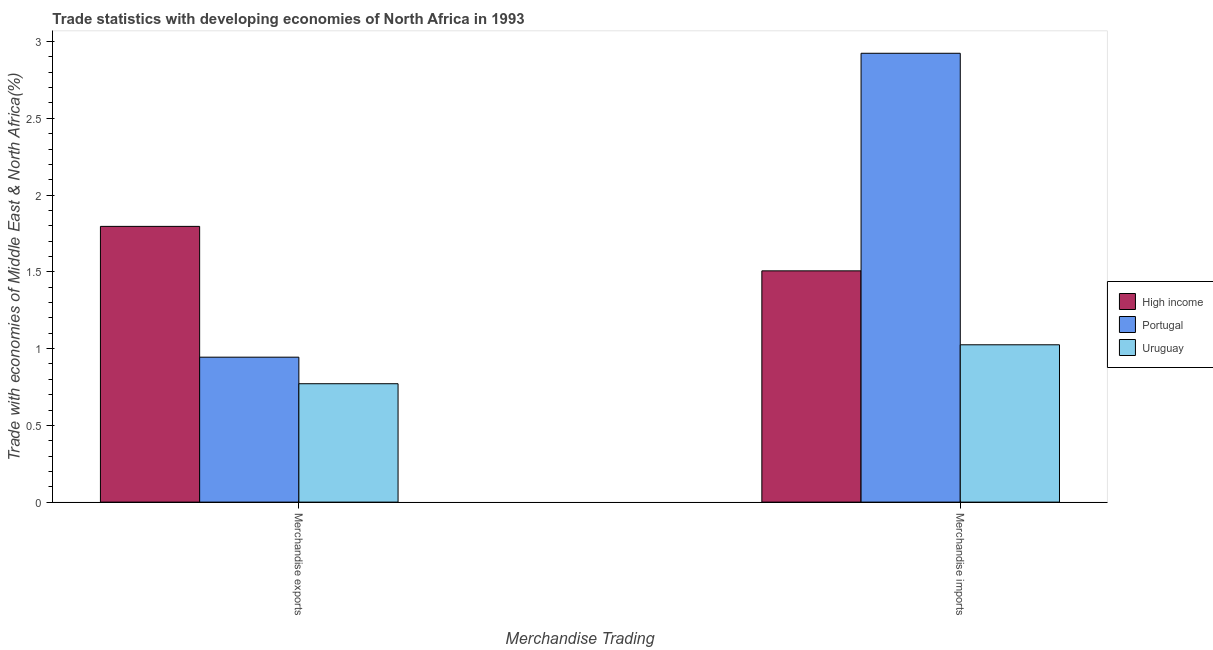How many different coloured bars are there?
Your answer should be very brief. 3. Are the number of bars per tick equal to the number of legend labels?
Your answer should be very brief. Yes. Are the number of bars on each tick of the X-axis equal?
Offer a terse response. Yes. How many bars are there on the 2nd tick from the right?
Your response must be concise. 3. What is the merchandise imports in Portugal?
Ensure brevity in your answer.  2.92. Across all countries, what is the maximum merchandise imports?
Provide a succinct answer. 2.92. Across all countries, what is the minimum merchandise imports?
Provide a succinct answer. 1.02. In which country was the merchandise imports minimum?
Your answer should be very brief. Uruguay. What is the total merchandise exports in the graph?
Offer a terse response. 3.51. What is the difference between the merchandise exports in Portugal and that in High income?
Offer a terse response. -0.85. What is the difference between the merchandise imports in Uruguay and the merchandise exports in High income?
Offer a terse response. -0.77. What is the average merchandise exports per country?
Your answer should be very brief. 1.17. What is the difference between the merchandise exports and merchandise imports in Portugal?
Keep it short and to the point. -1.98. What is the ratio of the merchandise imports in High income to that in Portugal?
Keep it short and to the point. 0.52. Is the merchandise imports in Uruguay less than that in Portugal?
Provide a succinct answer. Yes. What does the 2nd bar from the left in Merchandise exports represents?
Your response must be concise. Portugal. How many bars are there?
Your response must be concise. 6. Are all the bars in the graph horizontal?
Your response must be concise. No. What is the difference between two consecutive major ticks on the Y-axis?
Your answer should be compact. 0.5. Does the graph contain grids?
Ensure brevity in your answer.  No. Where does the legend appear in the graph?
Give a very brief answer. Center right. How many legend labels are there?
Provide a succinct answer. 3. What is the title of the graph?
Ensure brevity in your answer.  Trade statistics with developing economies of North Africa in 1993. What is the label or title of the X-axis?
Provide a succinct answer. Merchandise Trading. What is the label or title of the Y-axis?
Offer a very short reply. Trade with economies of Middle East & North Africa(%). What is the Trade with economies of Middle East & North Africa(%) of High income in Merchandise exports?
Keep it short and to the point. 1.8. What is the Trade with economies of Middle East & North Africa(%) of Portugal in Merchandise exports?
Your response must be concise. 0.94. What is the Trade with economies of Middle East & North Africa(%) of Uruguay in Merchandise exports?
Your answer should be compact. 0.77. What is the Trade with economies of Middle East & North Africa(%) of High income in Merchandise imports?
Make the answer very short. 1.51. What is the Trade with economies of Middle East & North Africa(%) in Portugal in Merchandise imports?
Provide a succinct answer. 2.92. What is the Trade with economies of Middle East & North Africa(%) in Uruguay in Merchandise imports?
Offer a terse response. 1.02. Across all Merchandise Trading, what is the maximum Trade with economies of Middle East & North Africa(%) of High income?
Keep it short and to the point. 1.8. Across all Merchandise Trading, what is the maximum Trade with economies of Middle East & North Africa(%) of Portugal?
Make the answer very short. 2.92. Across all Merchandise Trading, what is the maximum Trade with economies of Middle East & North Africa(%) of Uruguay?
Keep it short and to the point. 1.02. Across all Merchandise Trading, what is the minimum Trade with economies of Middle East & North Africa(%) in High income?
Your response must be concise. 1.51. Across all Merchandise Trading, what is the minimum Trade with economies of Middle East & North Africa(%) in Portugal?
Offer a terse response. 0.94. Across all Merchandise Trading, what is the minimum Trade with economies of Middle East & North Africa(%) in Uruguay?
Offer a very short reply. 0.77. What is the total Trade with economies of Middle East & North Africa(%) of High income in the graph?
Your answer should be very brief. 3.3. What is the total Trade with economies of Middle East & North Africa(%) in Portugal in the graph?
Keep it short and to the point. 3.87. What is the total Trade with economies of Middle East & North Africa(%) of Uruguay in the graph?
Your answer should be very brief. 1.8. What is the difference between the Trade with economies of Middle East & North Africa(%) in High income in Merchandise exports and that in Merchandise imports?
Provide a succinct answer. 0.29. What is the difference between the Trade with economies of Middle East & North Africa(%) in Portugal in Merchandise exports and that in Merchandise imports?
Keep it short and to the point. -1.98. What is the difference between the Trade with economies of Middle East & North Africa(%) of Uruguay in Merchandise exports and that in Merchandise imports?
Offer a terse response. -0.25. What is the difference between the Trade with economies of Middle East & North Africa(%) of High income in Merchandise exports and the Trade with economies of Middle East & North Africa(%) of Portugal in Merchandise imports?
Provide a succinct answer. -1.13. What is the difference between the Trade with economies of Middle East & North Africa(%) of High income in Merchandise exports and the Trade with economies of Middle East & North Africa(%) of Uruguay in Merchandise imports?
Make the answer very short. 0.77. What is the difference between the Trade with economies of Middle East & North Africa(%) in Portugal in Merchandise exports and the Trade with economies of Middle East & North Africa(%) in Uruguay in Merchandise imports?
Keep it short and to the point. -0.08. What is the average Trade with economies of Middle East & North Africa(%) of High income per Merchandise Trading?
Make the answer very short. 1.65. What is the average Trade with economies of Middle East & North Africa(%) of Portugal per Merchandise Trading?
Give a very brief answer. 1.93. What is the average Trade with economies of Middle East & North Africa(%) in Uruguay per Merchandise Trading?
Provide a succinct answer. 0.9. What is the difference between the Trade with economies of Middle East & North Africa(%) of High income and Trade with economies of Middle East & North Africa(%) of Portugal in Merchandise exports?
Offer a very short reply. 0.85. What is the difference between the Trade with economies of Middle East & North Africa(%) in High income and Trade with economies of Middle East & North Africa(%) in Uruguay in Merchandise exports?
Give a very brief answer. 1.02. What is the difference between the Trade with economies of Middle East & North Africa(%) in Portugal and Trade with economies of Middle East & North Africa(%) in Uruguay in Merchandise exports?
Ensure brevity in your answer.  0.17. What is the difference between the Trade with economies of Middle East & North Africa(%) in High income and Trade with economies of Middle East & North Africa(%) in Portugal in Merchandise imports?
Make the answer very short. -1.42. What is the difference between the Trade with economies of Middle East & North Africa(%) of High income and Trade with economies of Middle East & North Africa(%) of Uruguay in Merchandise imports?
Your answer should be very brief. 0.48. What is the difference between the Trade with economies of Middle East & North Africa(%) of Portugal and Trade with economies of Middle East & North Africa(%) of Uruguay in Merchandise imports?
Provide a succinct answer. 1.9. What is the ratio of the Trade with economies of Middle East & North Africa(%) of High income in Merchandise exports to that in Merchandise imports?
Your answer should be very brief. 1.19. What is the ratio of the Trade with economies of Middle East & North Africa(%) of Portugal in Merchandise exports to that in Merchandise imports?
Make the answer very short. 0.32. What is the ratio of the Trade with economies of Middle East & North Africa(%) in Uruguay in Merchandise exports to that in Merchandise imports?
Keep it short and to the point. 0.75. What is the difference between the highest and the second highest Trade with economies of Middle East & North Africa(%) in High income?
Make the answer very short. 0.29. What is the difference between the highest and the second highest Trade with economies of Middle East & North Africa(%) in Portugal?
Ensure brevity in your answer.  1.98. What is the difference between the highest and the second highest Trade with economies of Middle East & North Africa(%) of Uruguay?
Make the answer very short. 0.25. What is the difference between the highest and the lowest Trade with economies of Middle East & North Africa(%) of High income?
Ensure brevity in your answer.  0.29. What is the difference between the highest and the lowest Trade with economies of Middle East & North Africa(%) in Portugal?
Offer a terse response. 1.98. What is the difference between the highest and the lowest Trade with economies of Middle East & North Africa(%) in Uruguay?
Your answer should be very brief. 0.25. 